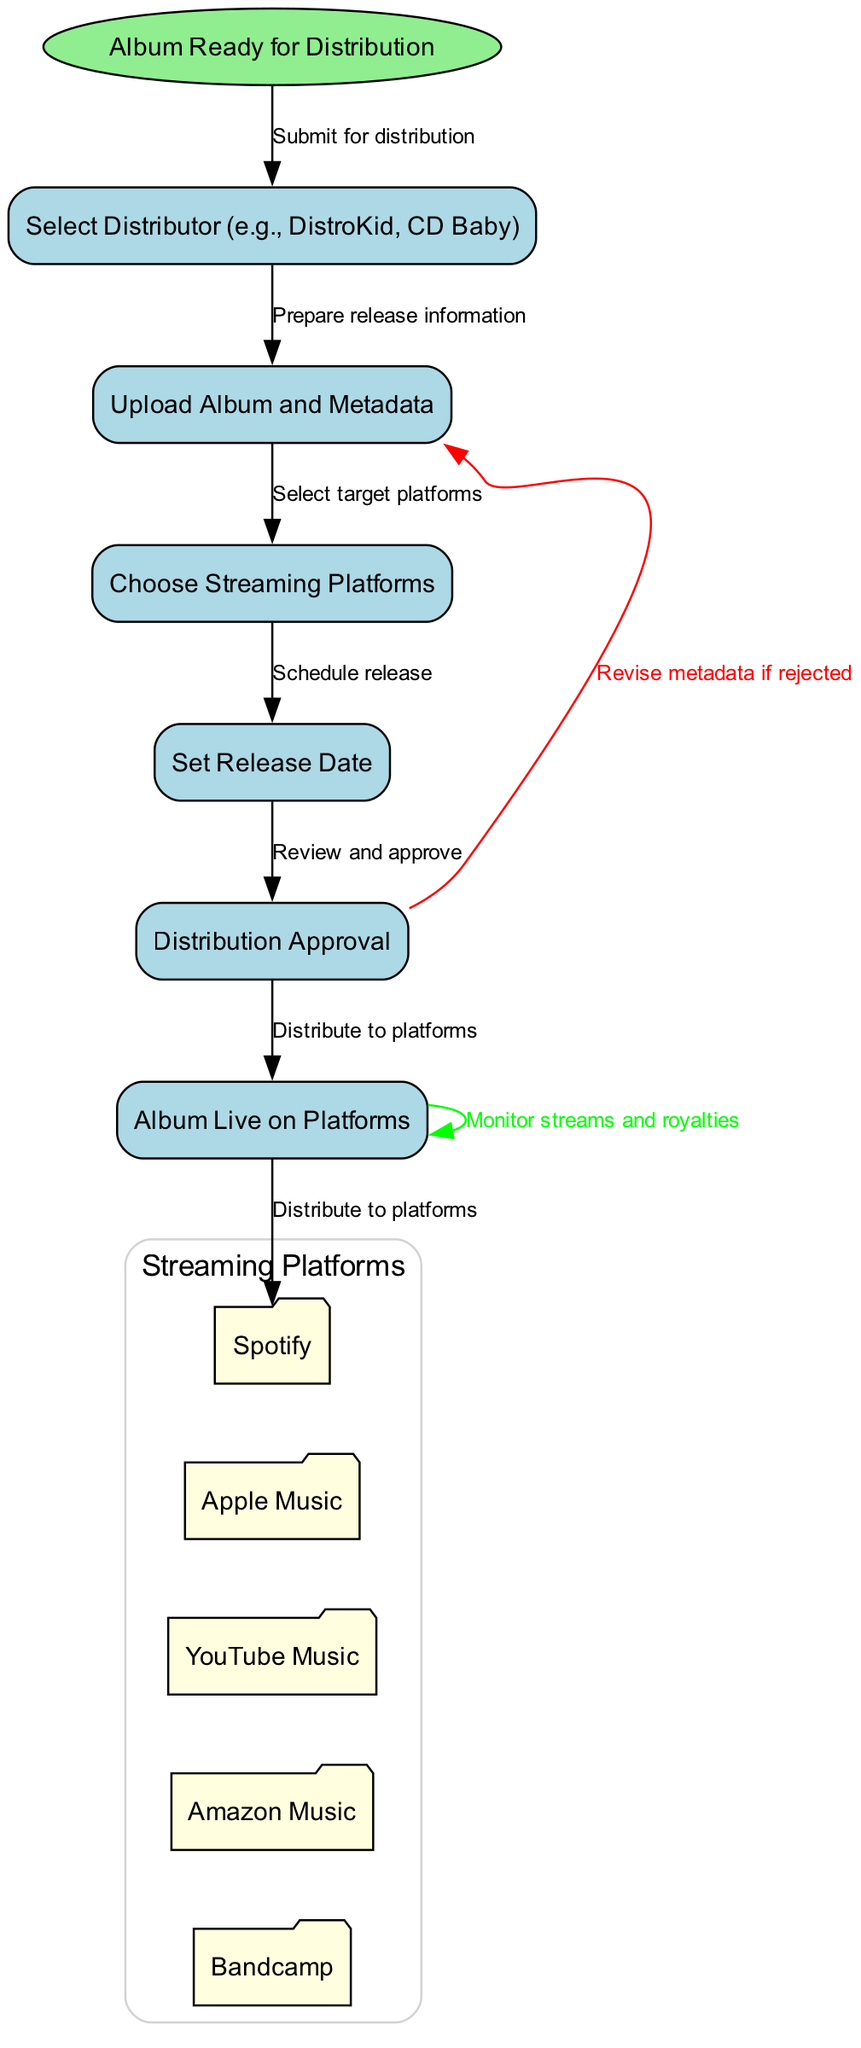What is the starting point of the distribution process? The starting point is indicated by the "Album Ready for Distribution" node, which marks where the process originates.
Answer: Album Ready for Distribution How many streaming platforms are listed in the diagram? The diagram features five streaming platforms: Spotify, Apple Music, YouTube Music, Amazon Music, and Bandcamp, which can be counted visually.
Answer: 5 What is the first action in the distribution process? The first action in the process is "Select Distributor," which is connected directly from the starting node to represent the initial step in the flowchart.
Answer: Select Distributor What happens if the distribution is not approved? If distribution is not approved, the process loops back to "Upload Album and Metadata," indicating that the metadata must be revised before resubmitting.
Answer: Revise metadata if rejected What step comes directly after choosing streaming platforms? After choosing the streaming platforms, the next step in the process is "Set Release Date," which continues the flow of actions required for distribution.
Answer: Set Release Date Which streaming platform is the first in the list? The first streaming platform listed in the diagram is "Spotify," which is the first node under the cluster labeled 'Streaming Platforms'.
Answer: Spotify What action must occur before the album goes live on platforms? Before the album goes live on platforms, "Distribution Approval" must occur, indicating that all necessary reviews and checks are completed.
Answer: Distribution Approval What feedback is given after the album goes live? Once the album is live, the feedback is to "Monitor streams and royalties," indicating that the musician should keep track of performance metrics post-release.
Answer: Monitor streams and royalties What does the diagram indicate will happen after the metadata is revised? After revising the metadata, the process indicates that it must be resubmitted for "Distribution Approval," thus repeating that step in the flowchart.
Answer: Distribution Approval 